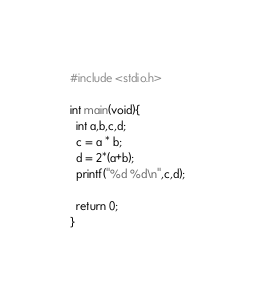Convert code to text. <code><loc_0><loc_0><loc_500><loc_500><_C_>#include <stdio.h>

int main(void){
  int a,b,c,d;
  c = a * b;
  d = 2*(a+b);
  printf("%d %d\n",c,d);

  return 0;
}</code> 